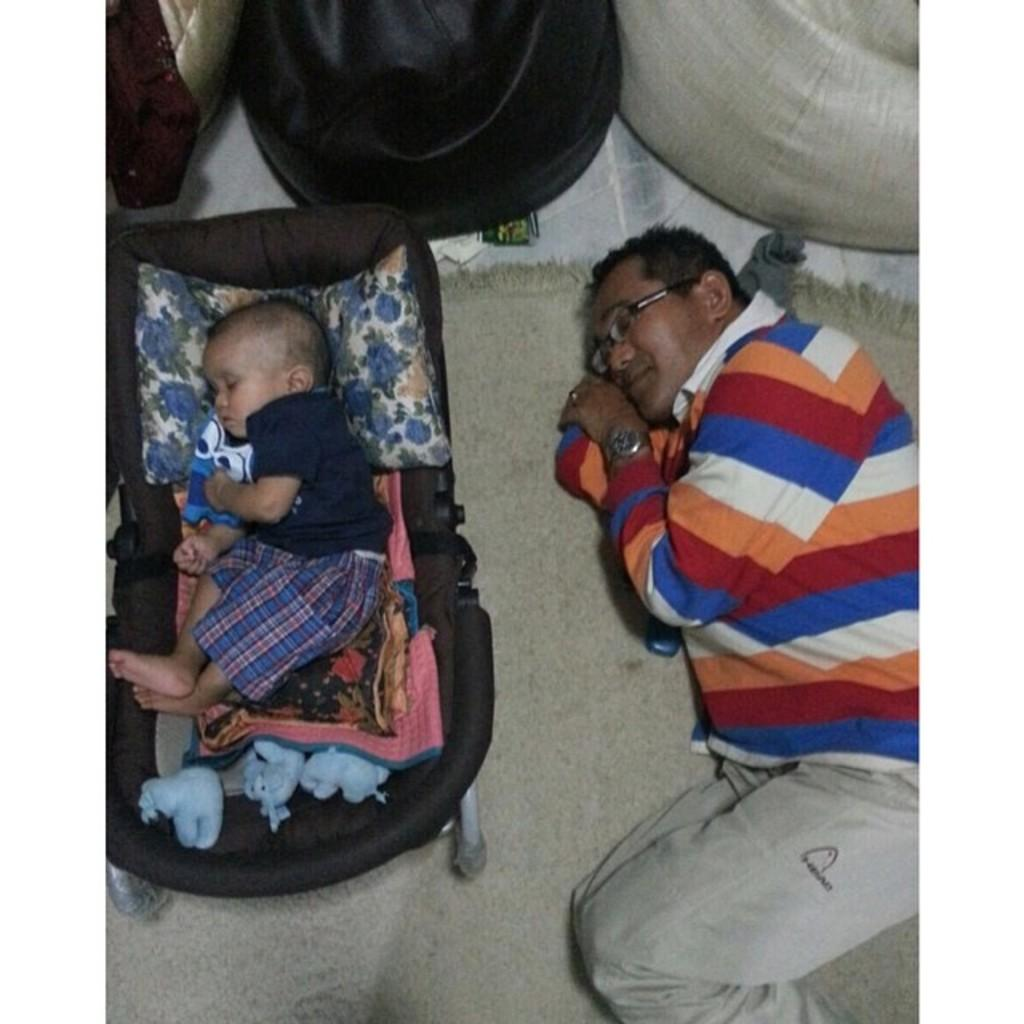Who is present in the image? There is a man and a baby in the image. What are the man and baby doing in the image? The man and baby are laying down. What is visible at the bottom of the image? There is a met at the bottom of the image. What accessories is the man wearing in the image? The man is wearing a watch and spectacles. What type of wine is being served in the image? There is no wine present in the image; it features a man and a baby laying down with a met at the bottom. 